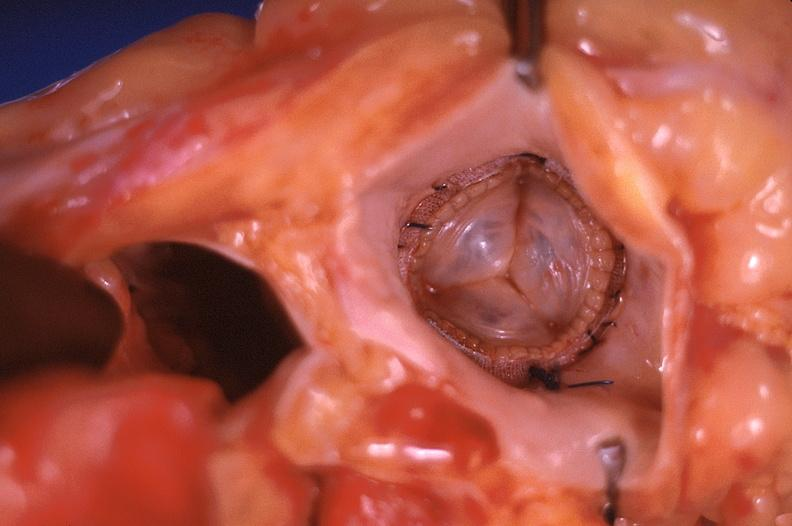s cardiovascular present?
Answer the question using a single word or phrase. Yes 